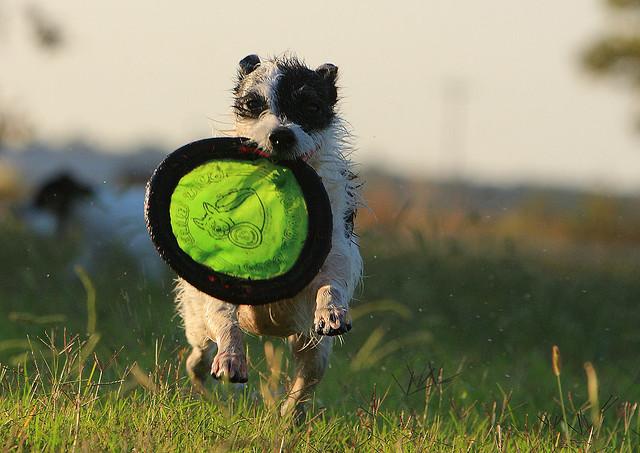What color is the right side of the dog's head?
Quick response, please. Black. Does this dog look like he is having fun?
Short answer required. Yes. Are all four of the dog's feet on the ground?
Give a very brief answer. No. 